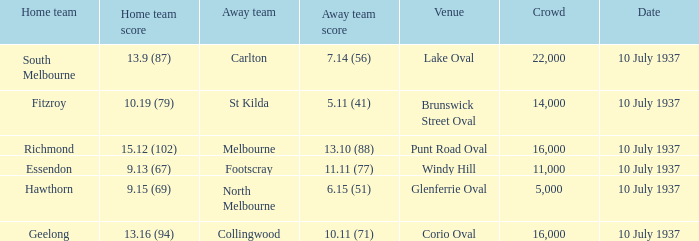What was the Venue of the North Melbourne Away Team? Glenferrie Oval. 